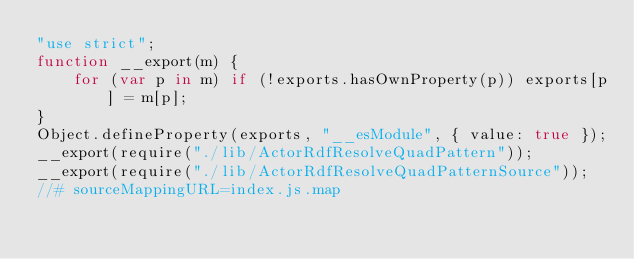<code> <loc_0><loc_0><loc_500><loc_500><_JavaScript_>"use strict";
function __export(m) {
    for (var p in m) if (!exports.hasOwnProperty(p)) exports[p] = m[p];
}
Object.defineProperty(exports, "__esModule", { value: true });
__export(require("./lib/ActorRdfResolveQuadPattern"));
__export(require("./lib/ActorRdfResolveQuadPatternSource"));
//# sourceMappingURL=index.js.map</code> 